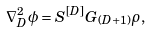Convert formula to latex. <formula><loc_0><loc_0><loc_500><loc_500>\nabla ^ { 2 } _ { D } \phi = S ^ { [ D ] } G _ { ( D + 1 ) } \rho ,</formula> 